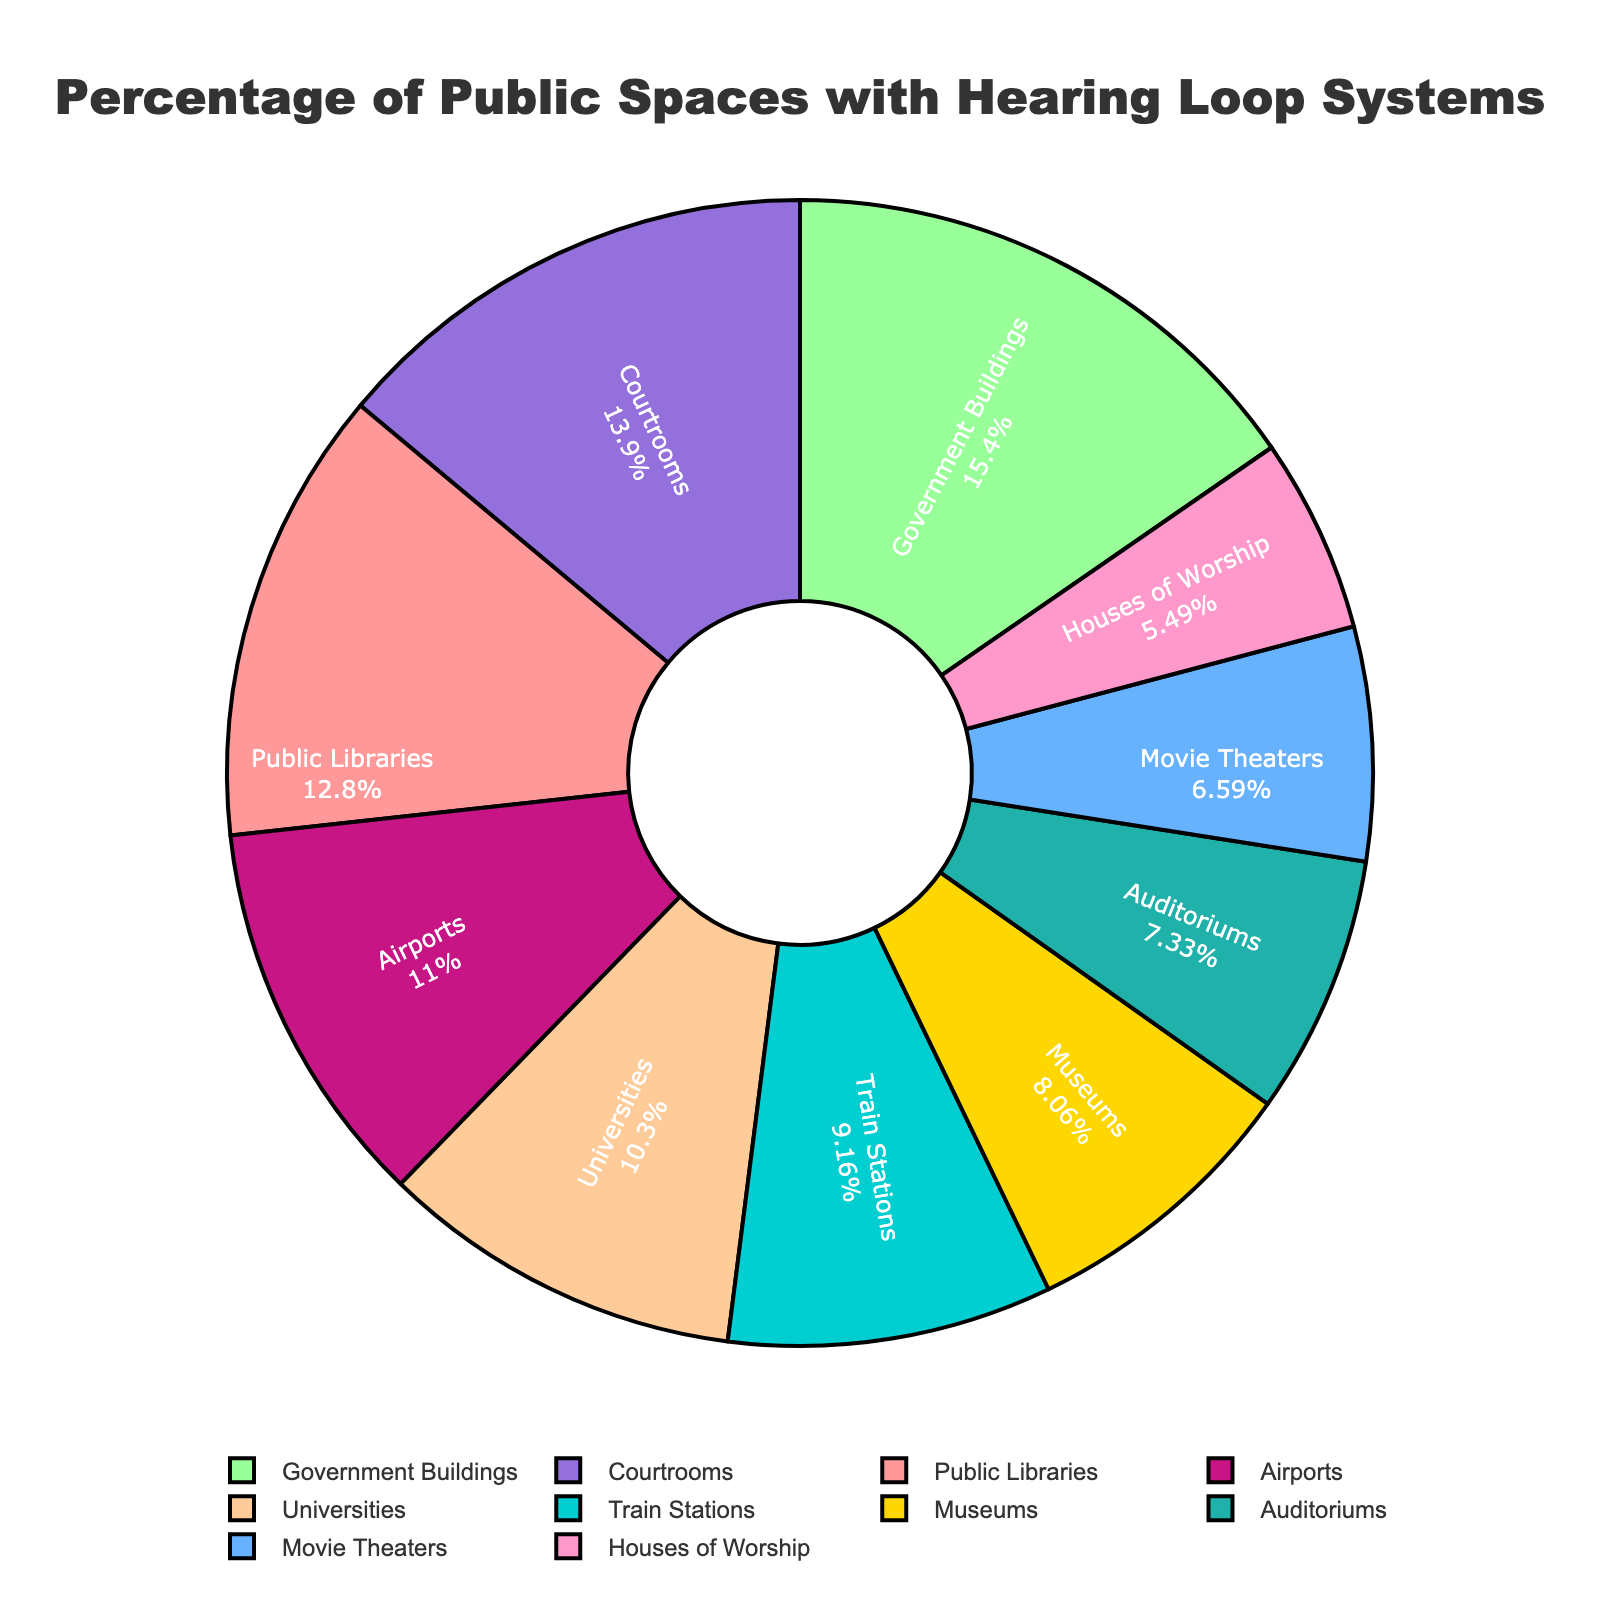Which location has the highest percentage of public spaces with hearing loop systems installed? According to the pie chart, Government Buildings have the largest slice, indicating the highest percentage.
Answer: Government Buildings Which location has the lowest percentage of public spaces with hearing loop systems installed? Based on the pie chart, Houses of Worship have the smallest slice.
Answer: Houses of Worship What is the total percentage of public spaces with hearing loop systems installed in Public Libraries, Airports, and Train Stations combined? Adding the percentages from the pie chart: 35% (Public Libraries) + 30% (Airports) + 25% (Train Stations) = 90%
Answer: 90% Among Museums and Universities, which one has a higher percentage of hearing loop systems installed? The pie chart shows that Museums have 22% and Universities have 28%, so Universities have a higher percentage.
Answer: Universities What is the percentage difference between Courtrooms and Movie Theaters? Subtract the percentage of Movie Theaters from Courtrooms: 38% (Courtrooms) - 18% (Movie Theaters) = 20%
Answer: 20% Which locations have a percentage of public spaces with hearing loop systems installed that is less than 20%? By looking at the pie chart, the locations are Movie Theaters (18%) and Houses of Worship (15%).
Answer: Movie Theaters, Houses of Worship Is the percentage of hearing loop systems in Airports greater than 25%? According to the pie chart, Airports have 30%, which is greater than 25%.
Answer: Yes Which color corresponds to Government Buildings in the pie chart? The slice for Government Buildings is represented in blue in the pie chart.
Answer: Blue How much smaller is the percentage of hearing loop systems in Movie Theaters compared to Public Libraries? Subtract the percentage of Movie Theaters from Public Libraries: 35% (Public Libraries) - 18% (Movie Theaters) = 17%
Answer: 17% Which has a higher total percentage of public spaces with hearing loop systems installed: Public Libraries and Auditors, or Airports and Train Stations? Adding the percentages for both groups: 35% (Public Libraries) + 20% (Auditors) = 55%; 30% (Airports) + 25% (Train Stations) = 55%. Both groups have the same percentage.
Answer: Both are equal 